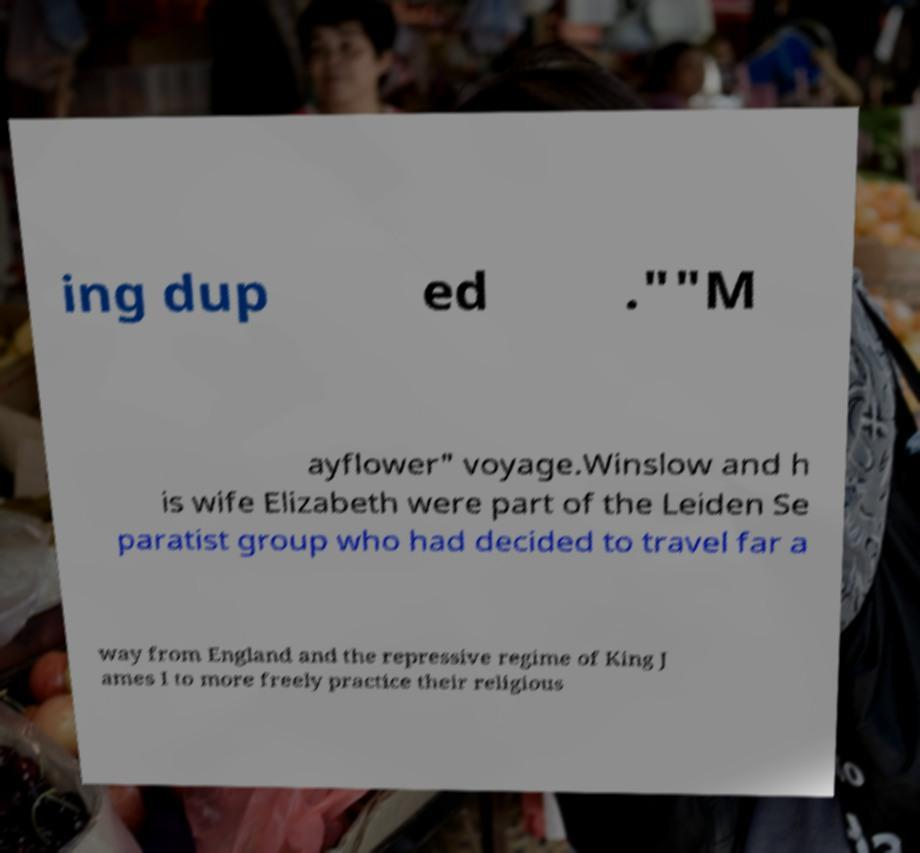Please identify and transcribe the text found in this image. ing dup ed .""M ayflower" voyage.Winslow and h is wife Elizabeth were part of the Leiden Se paratist group who had decided to travel far a way from England and the repressive regime of King J ames I to more freely practice their religious 